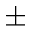Convert formula to latex. <formula><loc_0><loc_0><loc_500><loc_500>\pm</formula> 